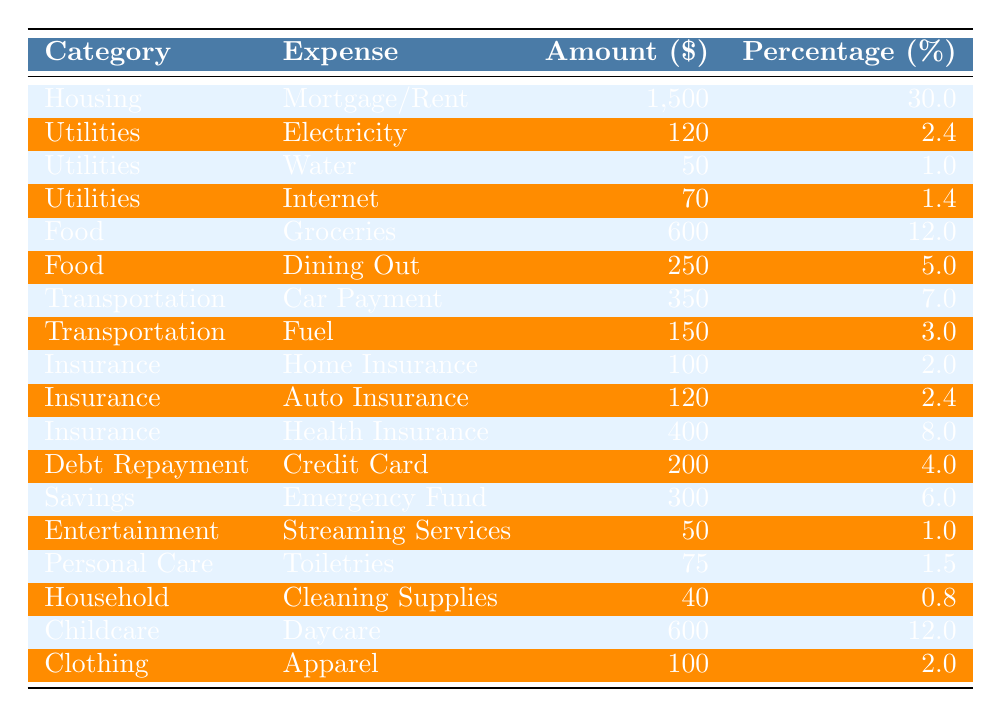What is the total monthly expenditure on utilities? To find the total monthly expenditure on utilities, I will sum the amounts for Electricity, Water, and Internet. The amounts are: 120 (Electricity) + 50 (Water) + 70 (Internet) = 240.
Answer: 240 What percentage of the budget is allocated to childcare? The percentage allocated to childcare is explicitly stated in the table under the Daycare expense, which is 12%.
Answer: 12% How much is spent on food (groceries + dining out)? To find the total spent on food, I will add the amounts for Groceries and Dining Out: 600 + 250 = 850.
Answer: 850 Is the amount spent on health insurance greater than the amount spent on home insurance? The amount for health insurance is 400, and the amount for home insurance is 100. Since 400 is greater than 100, the statement is true.
Answer: Yes What is the total percentage of the budget allocated to insurance expenses? To find this, I will sum the percentages for Home Insurance (2%), Auto Insurance (2.4%), and Health Insurance (8%): 2 + 2.4 + 8 = 12.4%.
Answer: 12.4% How much is allocated to savings compared to the total spent on debt repayment? The amount allocated to savings (Emergency Fund) is 300, and the amount spent on debt repayment (Credit Card) is 200. Therefore, savings are higher, as 300 > 200.
Answer: Yes What is the average expenditure on personal care and household supplies? Personal care (Toiletries) costs 75, and household (Cleaning Supplies) costs 40. To find the average: (75 + 40) / 2 = 57.5.
Answer: 57.5 Which category has the highest percentage allocation, and what is that percentage? By reviewing the table, I see that Housing (Mortgage/Rent) has the highest percentage at 30%.
Answer: 30 What is the total amount spent on entertainment and personal care combined? The total amount for entertainment (Streaming Services, 50) and personal care (Toiletries, 75) is 50 + 75 = 125.
Answer: 125 If you combine the amounts spent on clothing and utilities, what is the total? The amount spent on clothing (Apparel) is 100, and the total for utilities (Electricity, Water, Internet) is 240. Adding these amounts: 100 + 240 = 340.
Answer: 340 